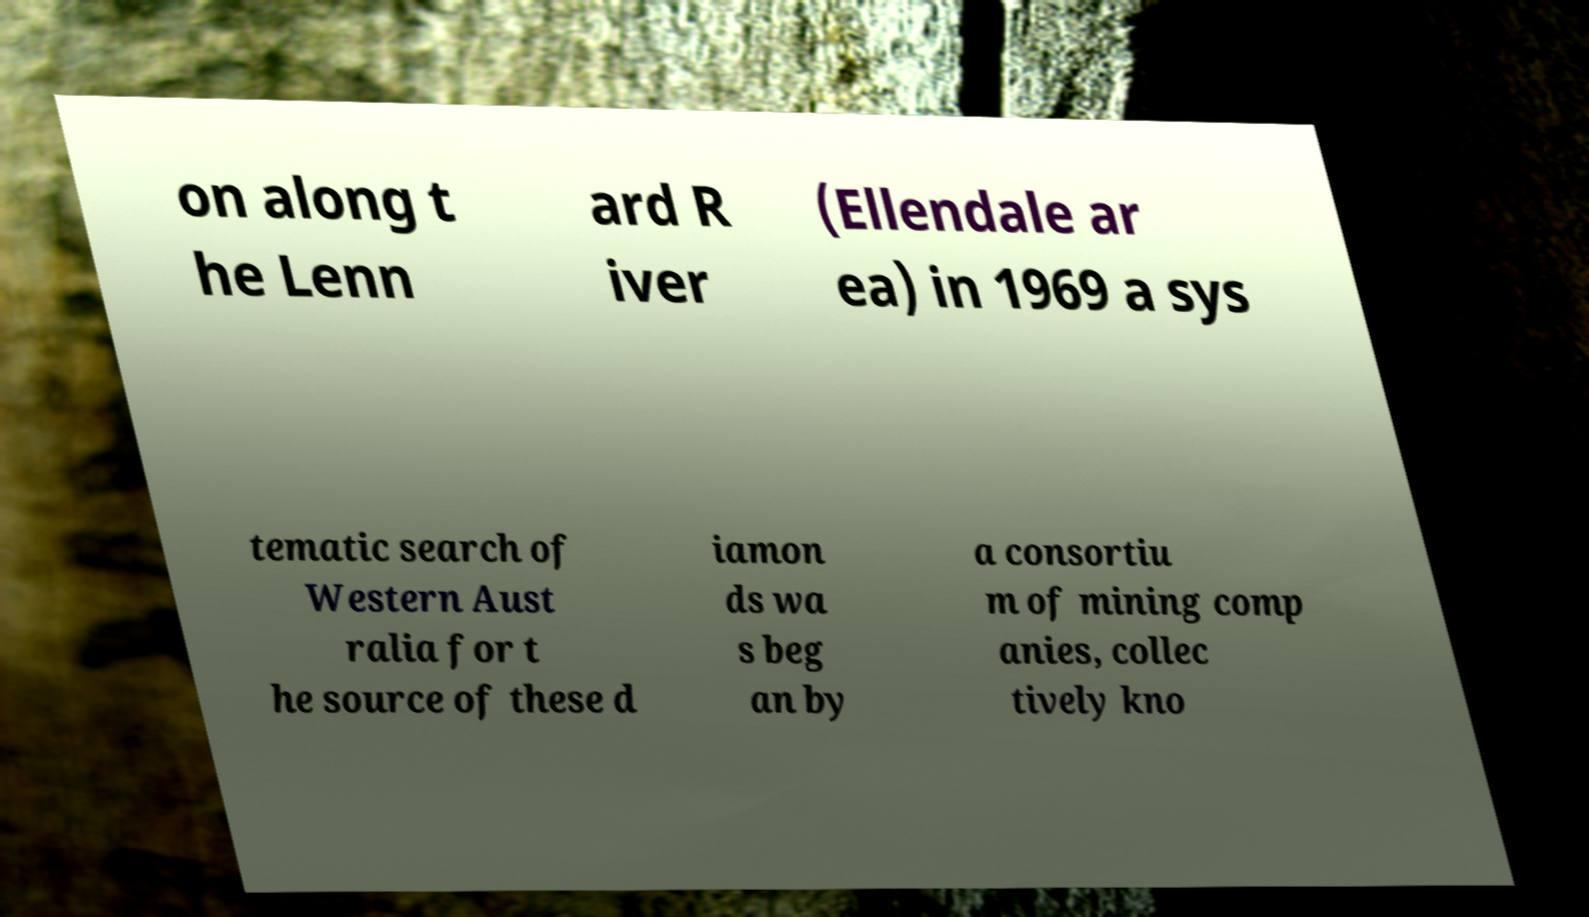Could you assist in decoding the text presented in this image and type it out clearly? on along t he Lenn ard R iver (Ellendale ar ea) in 1969 a sys tematic search of Western Aust ralia for t he source of these d iamon ds wa s beg an by a consortiu m of mining comp anies, collec tively kno 